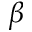Convert formula to latex. <formula><loc_0><loc_0><loc_500><loc_500>\beta</formula> 